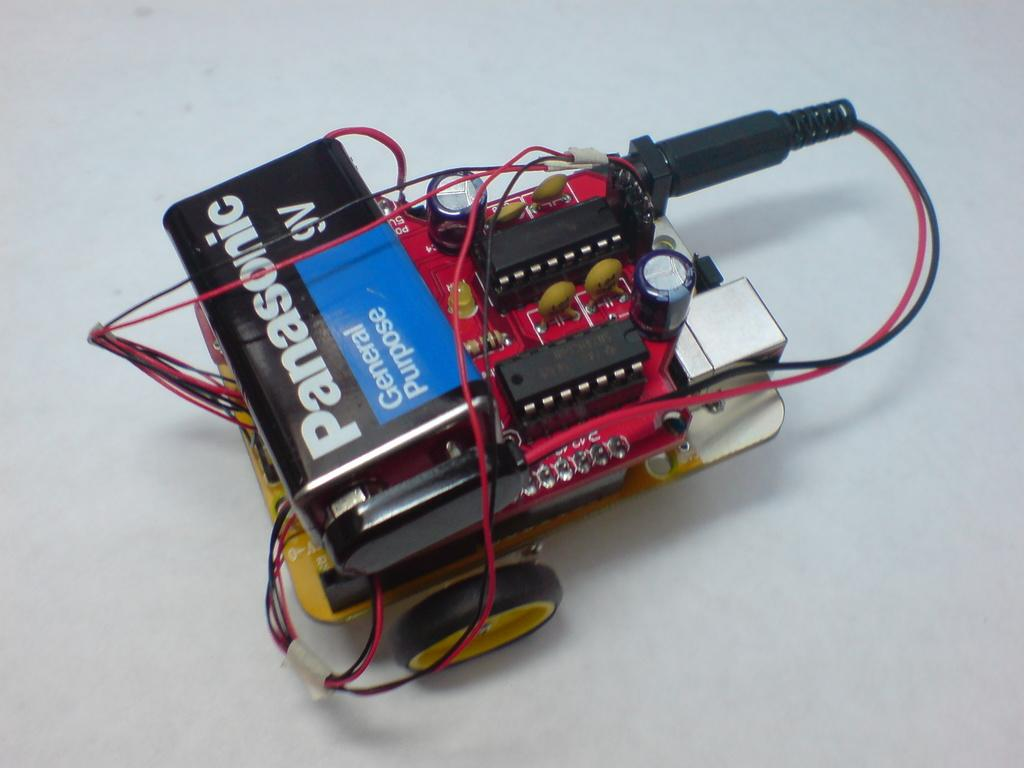What is the main object in the image? There is a spare part in the image. Where is the spare part located? The spare part is placed on a surface. What color is the feather that is illuminated by the lamp in the image? There is no feather or lamp present in the image; it only features a spare part placed on a surface. 